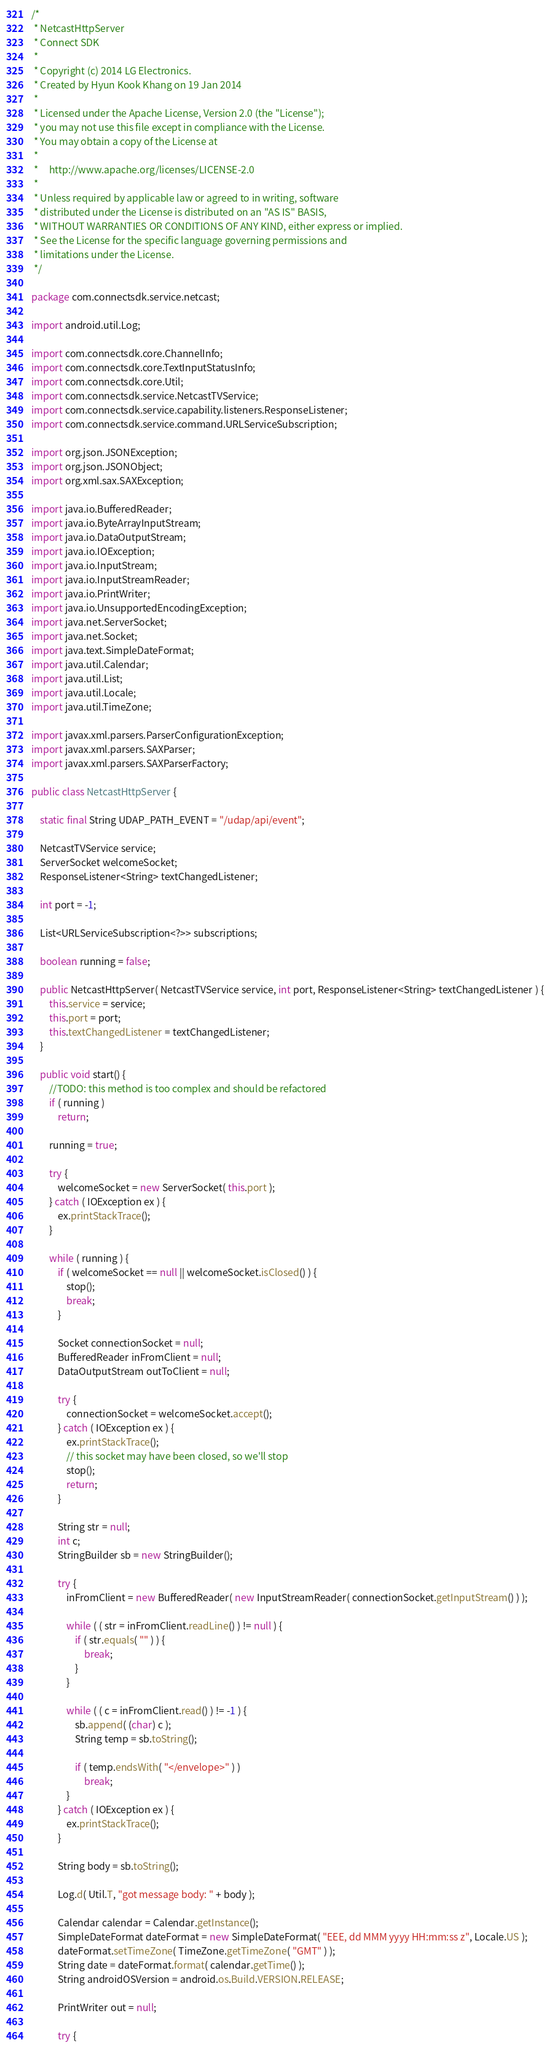<code> <loc_0><loc_0><loc_500><loc_500><_Java_>/*
 * NetcastHttpServer
 * Connect SDK
 * 
 * Copyright (c) 2014 LG Electronics.
 * Created by Hyun Kook Khang on 19 Jan 2014
 * 
 * Licensed under the Apache License, Version 2.0 (the "License");
 * you may not use this file except in compliance with the License.
 * You may obtain a copy of the License at
 *
 *     http://www.apache.org/licenses/LICENSE-2.0
 *
 * Unless required by applicable law or agreed to in writing, software
 * distributed under the License is distributed on an "AS IS" BASIS,
 * WITHOUT WARRANTIES OR CONDITIONS OF ANY KIND, either express or implied.
 * See the License for the specific language governing permissions and
 * limitations under the License.
 */

package com.connectsdk.service.netcast;

import android.util.Log;

import com.connectsdk.core.ChannelInfo;
import com.connectsdk.core.TextInputStatusInfo;
import com.connectsdk.core.Util;
import com.connectsdk.service.NetcastTVService;
import com.connectsdk.service.capability.listeners.ResponseListener;
import com.connectsdk.service.command.URLServiceSubscription;

import org.json.JSONException;
import org.json.JSONObject;
import org.xml.sax.SAXException;

import java.io.BufferedReader;
import java.io.ByteArrayInputStream;
import java.io.DataOutputStream;
import java.io.IOException;
import java.io.InputStream;
import java.io.InputStreamReader;
import java.io.PrintWriter;
import java.io.UnsupportedEncodingException;
import java.net.ServerSocket;
import java.net.Socket;
import java.text.SimpleDateFormat;
import java.util.Calendar;
import java.util.List;
import java.util.Locale;
import java.util.TimeZone;

import javax.xml.parsers.ParserConfigurationException;
import javax.xml.parsers.SAXParser;
import javax.xml.parsers.SAXParserFactory;

public class NetcastHttpServer {

    static final String UDAP_PATH_EVENT = "/udap/api/event";

    NetcastTVService service;
    ServerSocket welcomeSocket;
    ResponseListener<String> textChangedListener;

    int port = -1;

    List<URLServiceSubscription<?>> subscriptions;

    boolean running = false;

    public NetcastHttpServer( NetcastTVService service, int port, ResponseListener<String> textChangedListener ) {
        this.service = service;
        this.port = port;
        this.textChangedListener = textChangedListener;
    }

    public void start() {
        //TODO: this method is too complex and should be refactored
        if ( running )
            return;

        running = true;

        try {
            welcomeSocket = new ServerSocket( this.port );
        } catch ( IOException ex ) {
            ex.printStackTrace();
        }

        while ( running ) {
            if ( welcomeSocket == null || welcomeSocket.isClosed() ) {
                stop();
                break;
            }

            Socket connectionSocket = null;
            BufferedReader inFromClient = null;
            DataOutputStream outToClient = null;

            try {
                connectionSocket = welcomeSocket.accept();
            } catch ( IOException ex ) {
                ex.printStackTrace();
                // this socket may have been closed, so we'll stop
                stop();
                return;
            }

            String str = null;
            int c;
            StringBuilder sb = new StringBuilder();

            try {
                inFromClient = new BufferedReader( new InputStreamReader( connectionSocket.getInputStream() ) );

                while ( ( str = inFromClient.readLine() ) != null ) {
                    if ( str.equals( "" ) ) {
                        break;
                    }
                }

                while ( ( c = inFromClient.read() ) != -1 ) {
                    sb.append( (char) c );
                    String temp = sb.toString();

                    if ( temp.endsWith( "</envelope>" ) )
                        break;
                }
            } catch ( IOException ex ) {
                ex.printStackTrace();
            }

            String body = sb.toString();

            Log.d( Util.T, "got message body: " + body );

            Calendar calendar = Calendar.getInstance();
            SimpleDateFormat dateFormat = new SimpleDateFormat( "EEE, dd MMM yyyy HH:mm:ss z", Locale.US );
            dateFormat.setTimeZone( TimeZone.getTimeZone( "GMT" ) );
            String date = dateFormat.format( calendar.getTime() );
            String androidOSVersion = android.os.Build.VERSION.RELEASE;

            PrintWriter out = null;

            try {</code> 